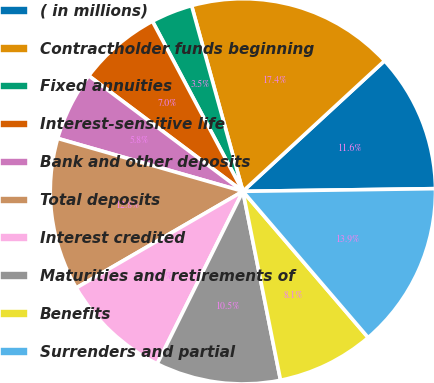Convert chart to OTSL. <chart><loc_0><loc_0><loc_500><loc_500><pie_chart><fcel>( in millions)<fcel>Contractholder funds beginning<fcel>Fixed annuities<fcel>Interest-sensitive life<fcel>Bank and other deposits<fcel>Total deposits<fcel>Interest credited<fcel>Maturities and retirements of<fcel>Benefits<fcel>Surrenders and partial<nl><fcel>11.63%<fcel>17.44%<fcel>3.49%<fcel>6.98%<fcel>5.81%<fcel>12.79%<fcel>9.3%<fcel>10.47%<fcel>8.14%<fcel>13.95%<nl></chart> 